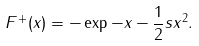Convert formula to latex. <formula><loc_0><loc_0><loc_500><loc_500>F ^ { + } ( x ) = - \exp { - x - \frac { 1 } { 2 } s x ^ { 2 } } .</formula> 